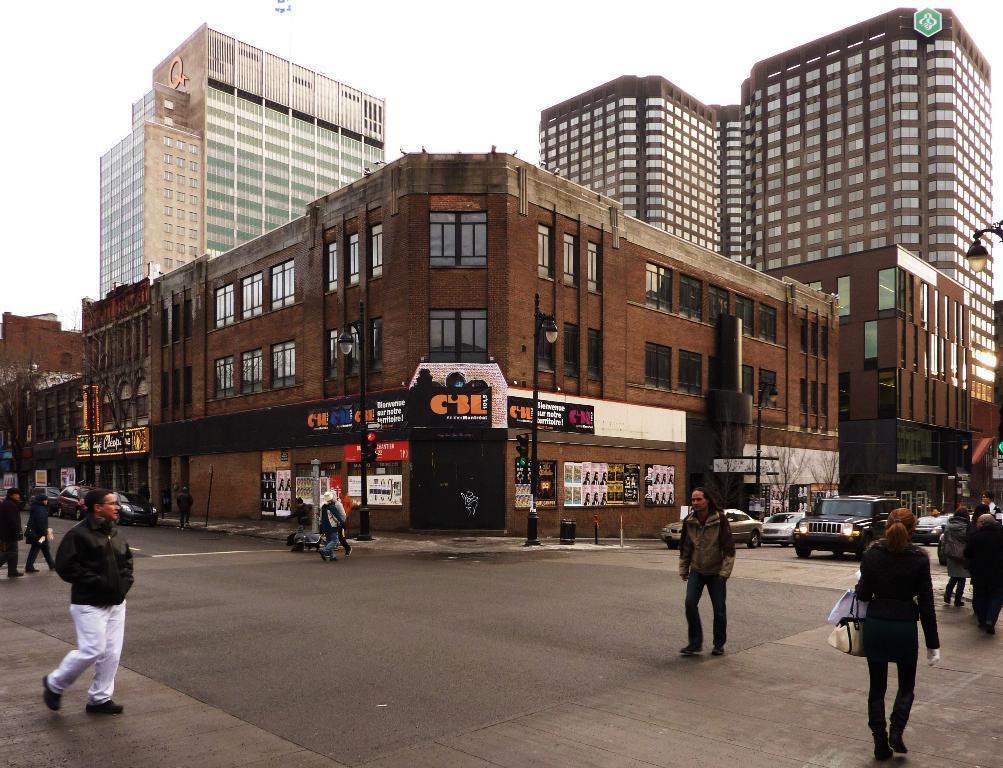Can you describe this image briefly? This image is taken outdoors. At the bottom of the image there is a road. At the top of the image there is a sky. In the middle of the image there are a few buildings with walls, windows, doors, roofs and balconies. There are a few poles with street lights and signal lights and there are a few boards with text on them. On the left and right sides of the image a few cars are moving on the road and a few people are walking on the road. 